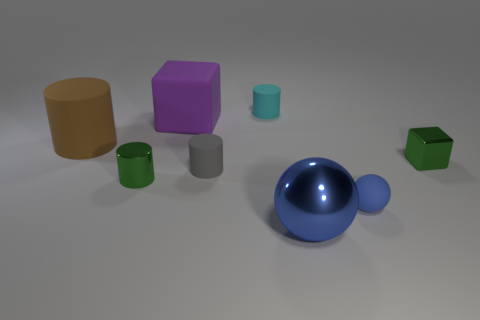Add 1 purple cylinders. How many objects exist? 9 Subtract all cubes. How many objects are left? 6 Add 2 small cyan cylinders. How many small cyan cylinders exist? 3 Subtract 0 red cubes. How many objects are left? 8 Subtract all small cyan matte things. Subtract all large brown cylinders. How many objects are left? 6 Add 5 gray matte objects. How many gray matte objects are left? 6 